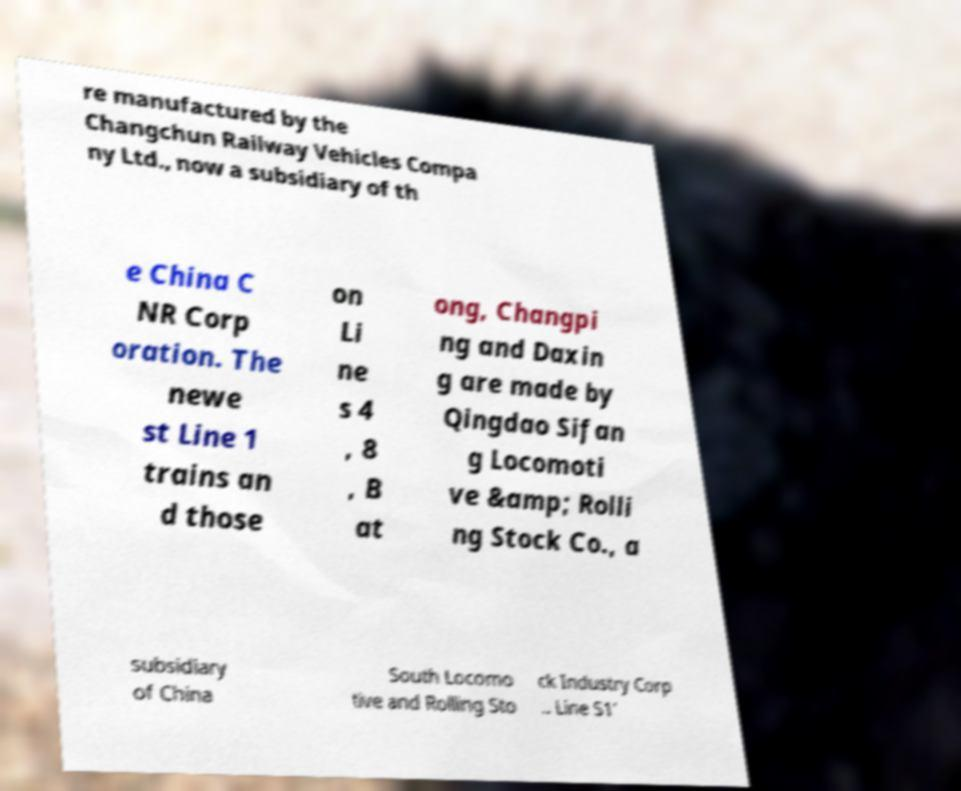Could you assist in decoding the text presented in this image and type it out clearly? re manufactured by the Changchun Railway Vehicles Compa ny Ltd., now a subsidiary of th e China C NR Corp oration. The newe st Line 1 trains an d those on Li ne s 4 , 8 , B at ong, Changpi ng and Daxin g are made by Qingdao Sifan g Locomoti ve &amp; Rolli ng Stock Co., a subsidiary of China South Locomo tive and Rolling Sto ck Industry Corp .. Line S1' 